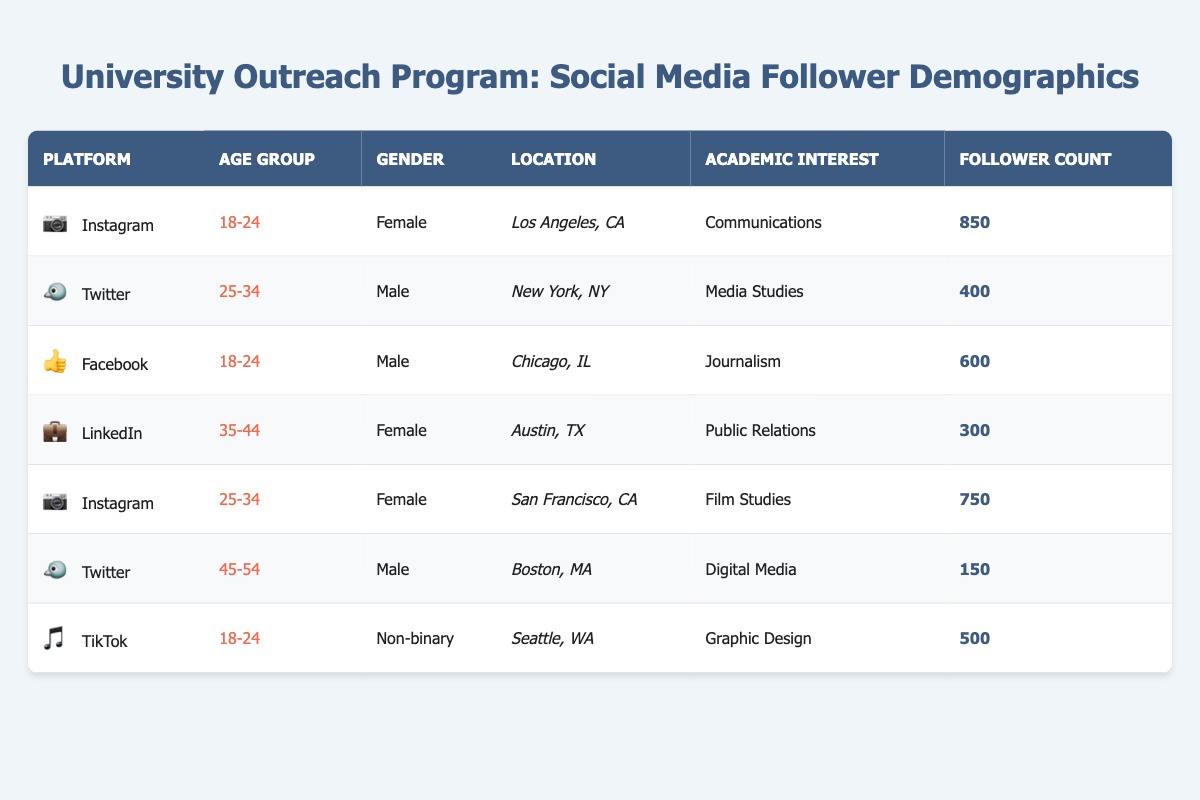What is the follower count for the Instagram users in the age group 18-24? There is one entry for Instagram followers in the age group 18-24, and it shows a follower count of 850.
Answer: 850 Is there a follower count greater than 600 for male users? The table shows one male user on Twitter with a count of 400 and another male user on Facebook with a count of 600, meaning there are no male users with a count greater than 600.
Answer: No What is the total follower count for all users on Instagram? There are two entries for Instagram: one with 850 followers in the age group 18-24 and another with 750 followers in the age group 25-34. Adding these together gives 850 + 750 = 1600.
Answer: 1600 How many followers are from individuals interested in Media Studies? There is one follower interested in Media Studies from New York, NY, associated with Twitter, who has a follower count of 400.
Answer: 400 Do any followers identify as non-binary? Yes, there is one entry for a non-binary user from Seattle, WA, with an interest in Graphic Design and a follower count of 500.
Answer: Yes What is the average follower count for females across all platforms? There are three female entries: 850 (Instagram, age 18-24), 750 (Instagram, age 25-34), and 300 (LinkedIn, age 35-44). Summing these gives 850 + 750 + 300 = 1900, and dividing by 3 gives an average count of 1900/3 = 633.33.
Answer: 633.33 What is the total number of followers across all platforms represented in the table? The total can be calculated by adding all the follower counts: 850 (Instagram) + 400 (Twitter) + 600 (Facebook) + 300 (LinkedIn) + 750 (Instagram) + 150 (Twitter) + 500 (TikTok) = 3250.
Answer: 3250 